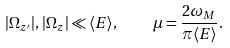<formula> <loc_0><loc_0><loc_500><loc_500>| \Omega _ { z ^ { \prime } } | , \, | \Omega _ { z } | \ll \langle E \rangle , \quad \mu = \frac { 2 \omega _ { M } } { \pi \langle E \rangle } .</formula> 